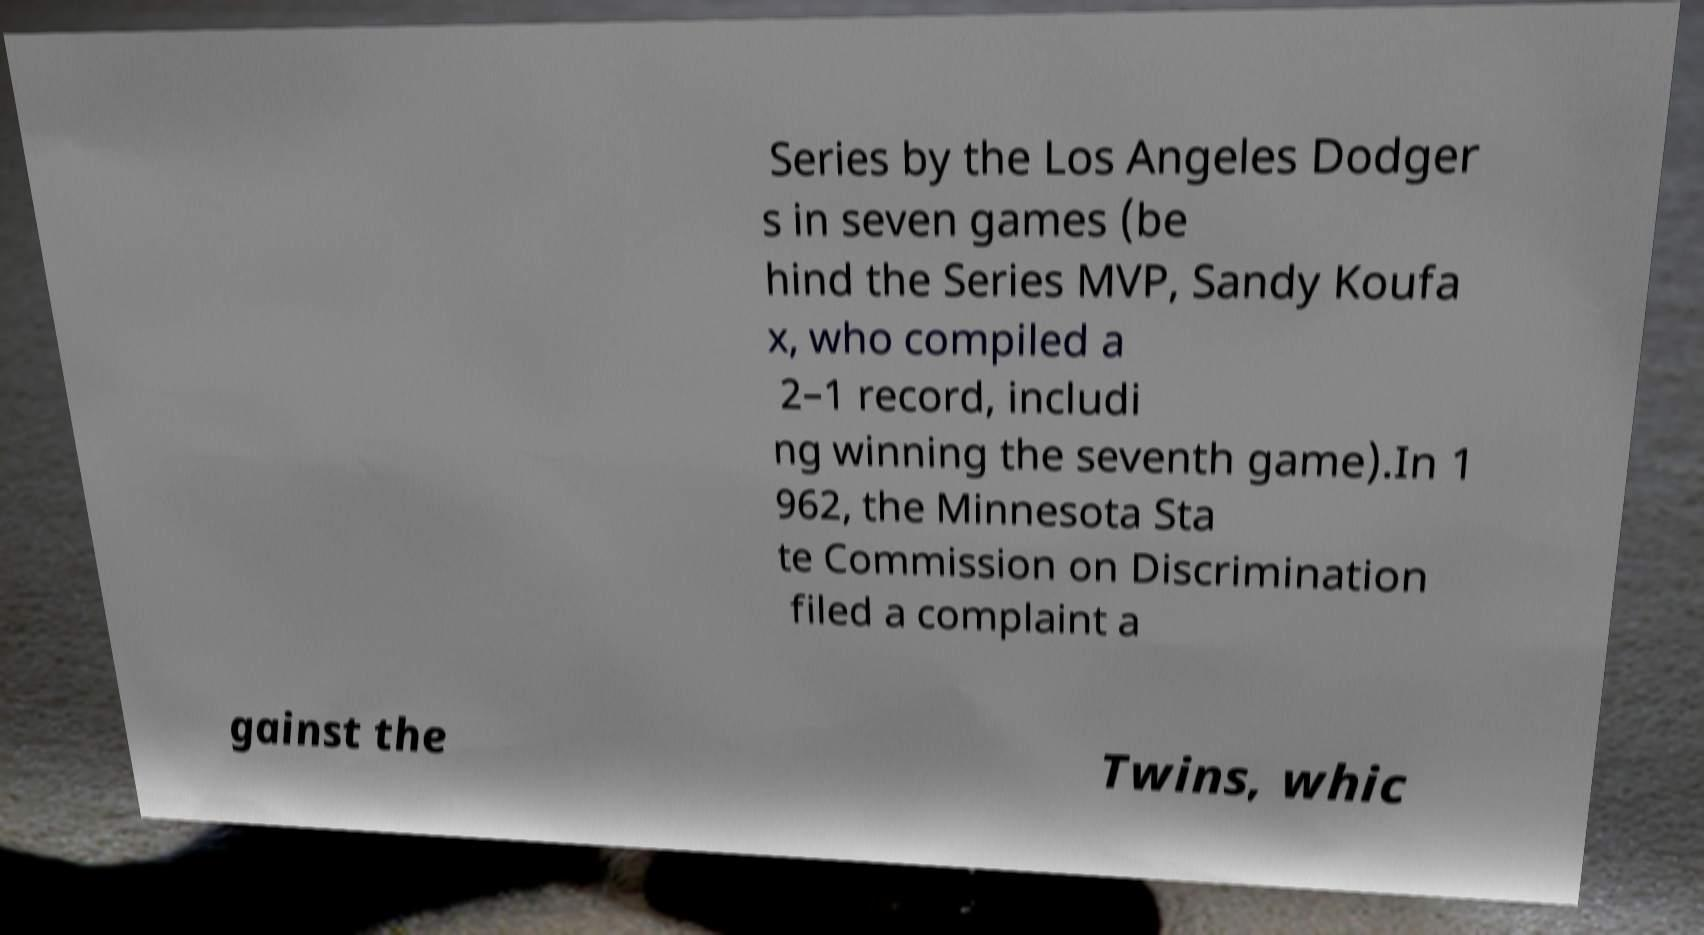I need the written content from this picture converted into text. Can you do that? Series by the Los Angeles Dodger s in seven games (be hind the Series MVP, Sandy Koufa x, who compiled a 2–1 record, includi ng winning the seventh game).In 1 962, the Minnesota Sta te Commission on Discrimination filed a complaint a gainst the Twins, whic 